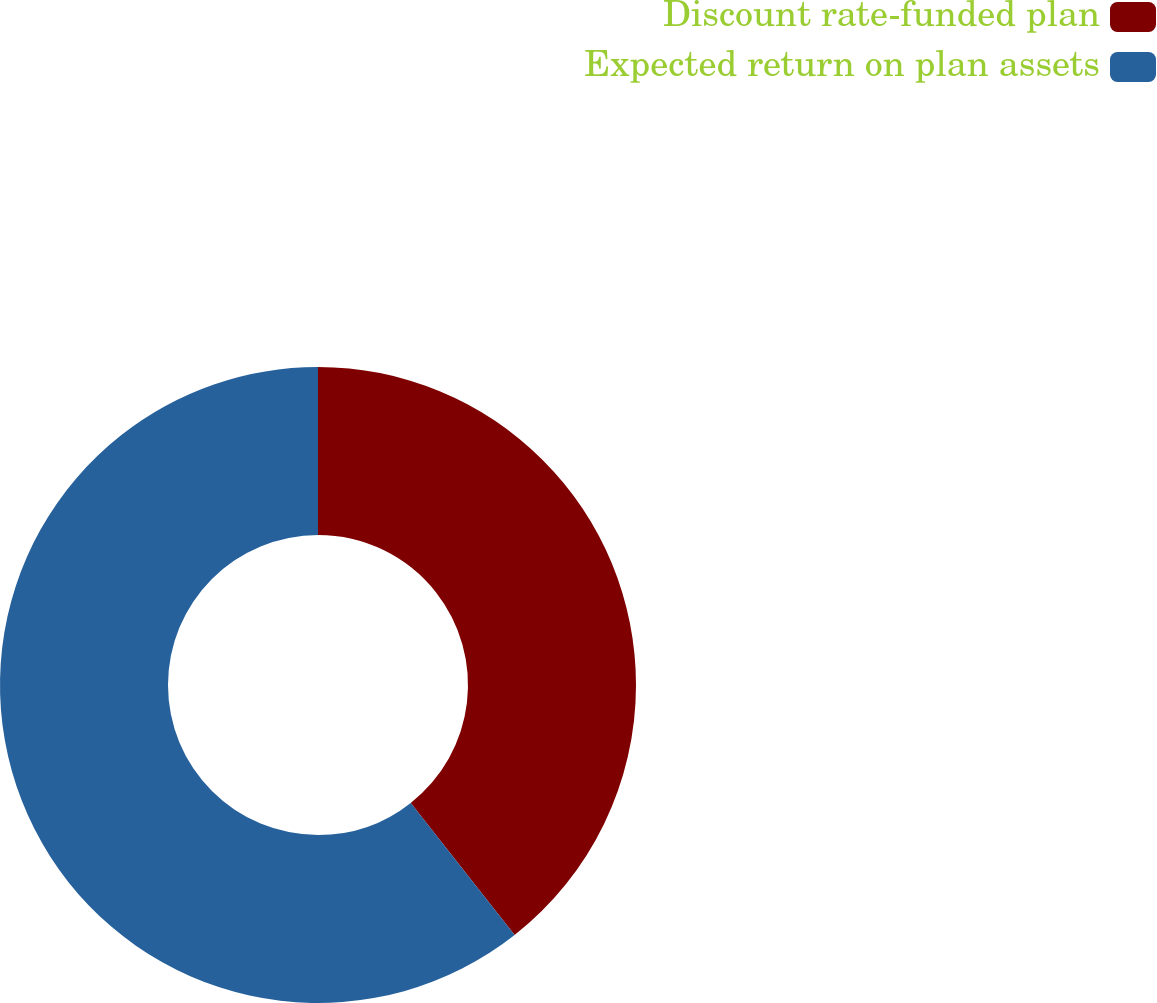Convert chart. <chart><loc_0><loc_0><loc_500><loc_500><pie_chart><fcel>Discount rate-funded plan<fcel>Expected return on plan assets<nl><fcel>39.39%<fcel>60.61%<nl></chart> 